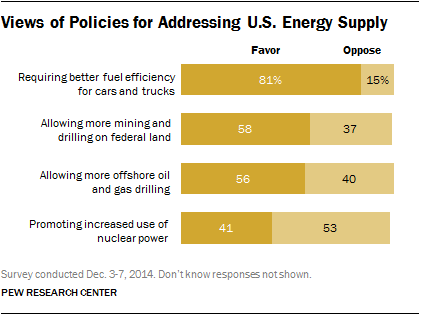List a handful of essential elements in this visual. Of the options available, two have opposing rates over 38%. Promoting increased use of nuclear power has the largest opposing rate. 